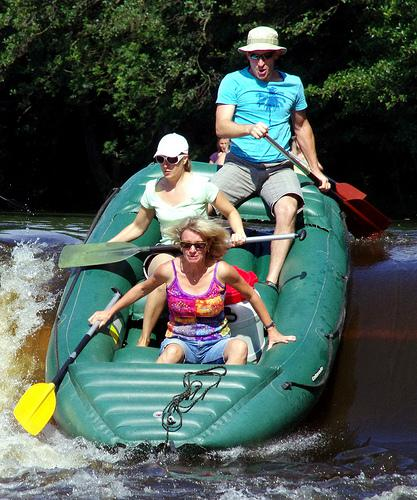Question: why are they holding paddles?
Choices:
A. To steer the raft.
B. To paddle the water.
C. To keep safe.
D. To row the boat.
Answer with the letter. Answer: A Question: what are the people doing?
Choices:
A. Playing basketball.
B. Rafting.
C. Reading books.
D. Relaxing.
Answer with the letter. Answer: B Question: when is this photo taken?
Choices:
A. Night time.
B. Daytime.
C. In the middle of the night.
D. In the morning.
Answer with the letter. Answer: B Question: where are the people?
Choices:
A. In a raft.
B. In a boat.
C. In a car.
D. On a train.
Answer with the letter. Answer: A 